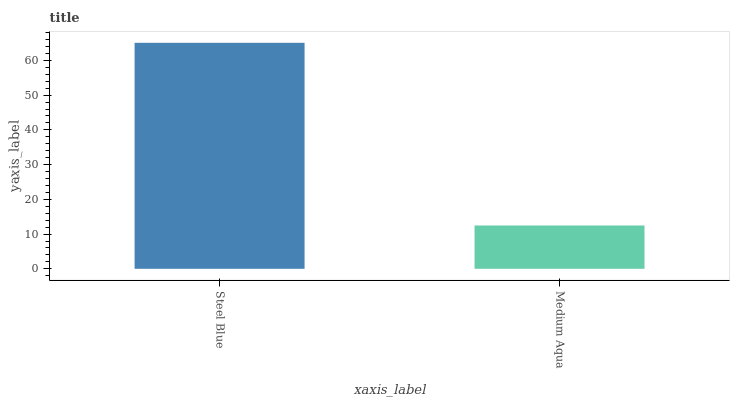Is Medium Aqua the minimum?
Answer yes or no. Yes. Is Steel Blue the maximum?
Answer yes or no. Yes. Is Medium Aqua the maximum?
Answer yes or no. No. Is Steel Blue greater than Medium Aqua?
Answer yes or no. Yes. Is Medium Aqua less than Steel Blue?
Answer yes or no. Yes. Is Medium Aqua greater than Steel Blue?
Answer yes or no. No. Is Steel Blue less than Medium Aqua?
Answer yes or no. No. Is Steel Blue the high median?
Answer yes or no. Yes. Is Medium Aqua the low median?
Answer yes or no. Yes. Is Medium Aqua the high median?
Answer yes or no. No. Is Steel Blue the low median?
Answer yes or no. No. 